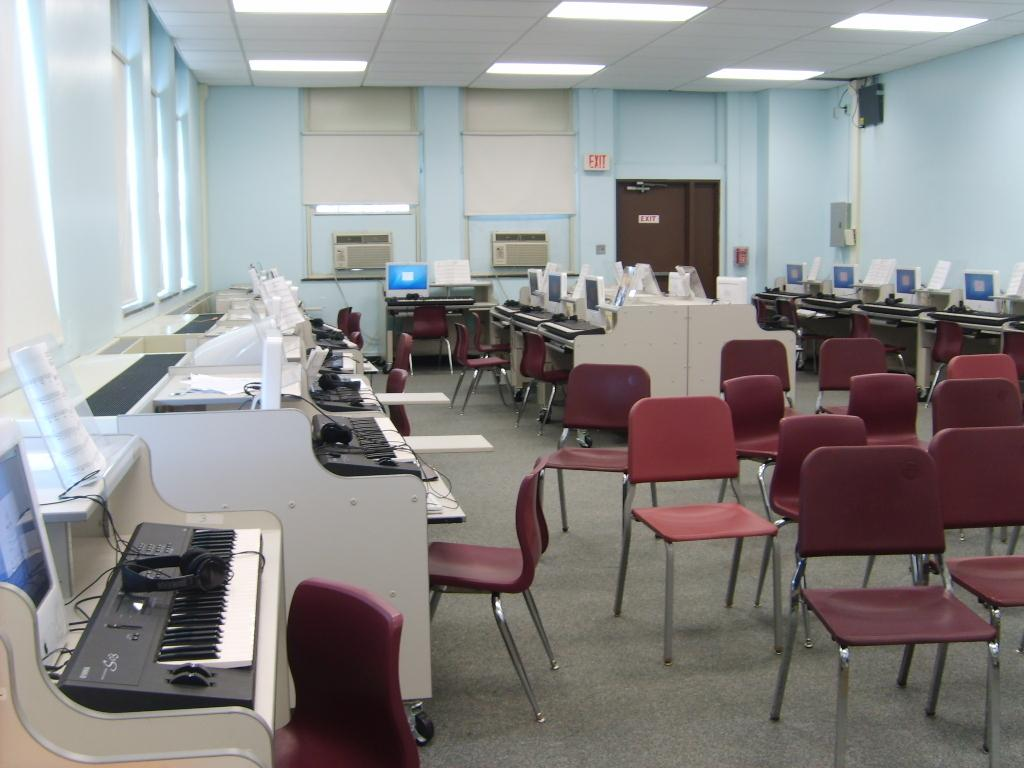What musical instrument is on the table in the room? There is a piano on a table in the room. What type of furniture is present in the room for seating? There are chairs in the room. What can be seen in the background of the room? There are monitors in the background of the room. What type of summer activity is taking place in the room? There is no indication of a summer activity in the room, as the image does not provide any information about the season or weather. 